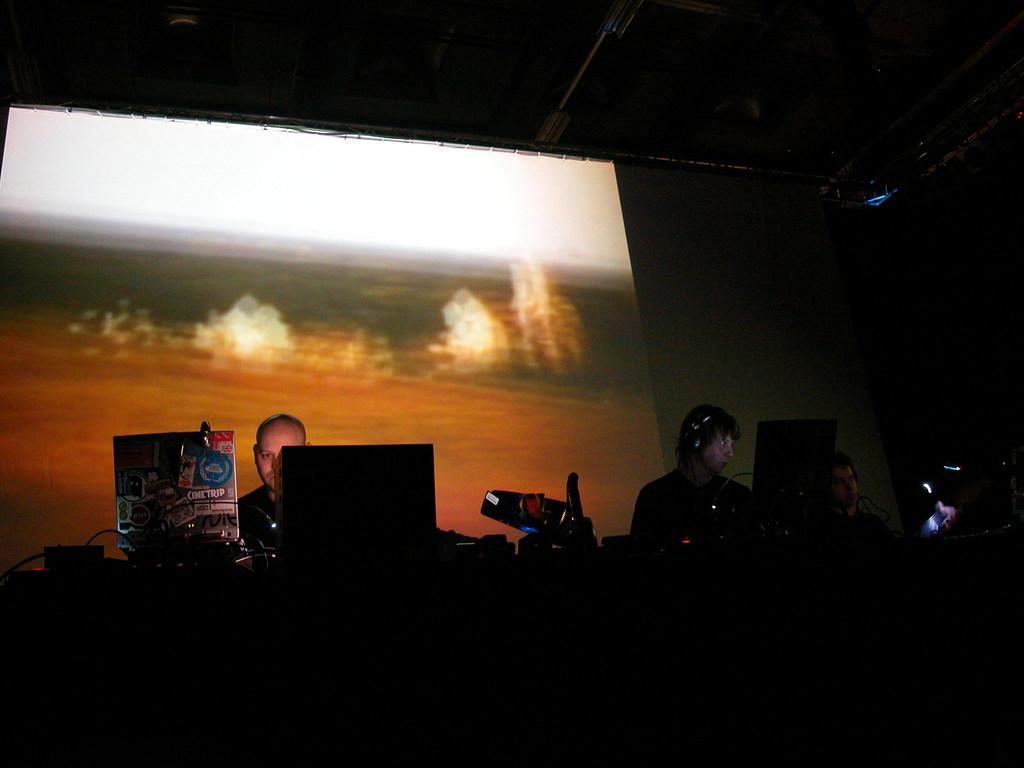How many people are in the image? There is a group of people in the image. What else can be seen in the image besides the people? There are wires, a board, electronic gadgets, and a screen visible in the image. What might the board be used for in the image? The board might be used for displaying information or instructions related to the electronic gadgets. Where is the screen located in the image? The screen is visible in the background of the image. What type of tin can be seen on the farm in the image? There is no farm or tin present in the image. How many rings are visible on the fingers of the people in the image? There is no information about rings on the fingers of the people in the image. 